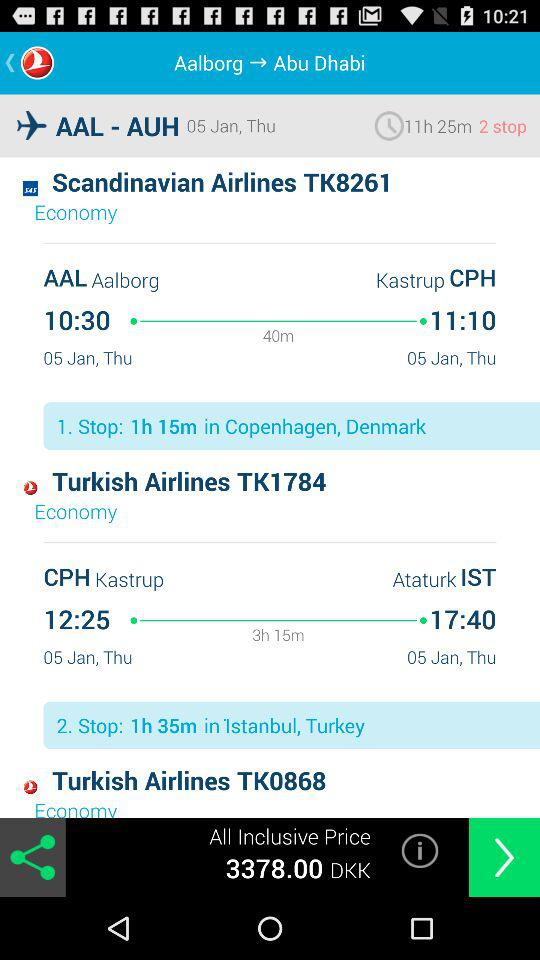What is the travel time of the "Turkish Airlines" flight from Kastrup to Ataturk? The travel time is 3 hours 15 minutes. 